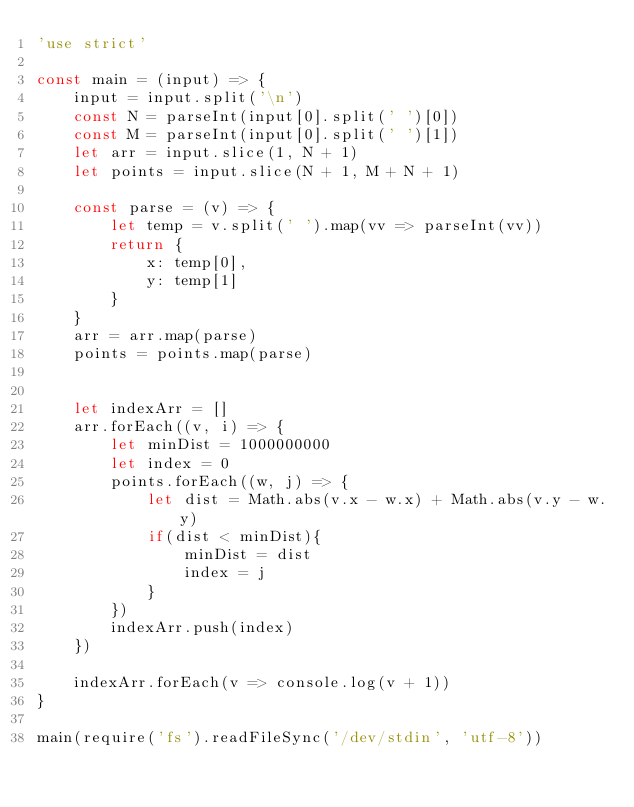Convert code to text. <code><loc_0><loc_0><loc_500><loc_500><_JavaScript_>'use strict'

const main = (input) => {
    input = input.split('\n')
    const N = parseInt(input[0].split(' ')[0])
    const M = parseInt(input[0].split(' ')[1])
    let arr = input.slice(1, N + 1)
    let points = input.slice(N + 1, M + N + 1)

    const parse = (v) => {
        let temp = v.split(' ').map(vv => parseInt(vv))
        return {
            x: temp[0],
            y: temp[1]
        }
    }
    arr = arr.map(parse)
    points = points.map(parse)


    let indexArr = []
    arr.forEach((v, i) => {
        let minDist = 1000000000
        let index = 0
        points.forEach((w, j) => {
            let dist = Math.abs(v.x - w.x) + Math.abs(v.y - w.y)
            if(dist < minDist){
                minDist = dist
                index = j
            }
        })
        indexArr.push(index)
    })

    indexArr.forEach(v => console.log(v + 1))
}

main(require('fs').readFileSync('/dev/stdin', 'utf-8'))</code> 